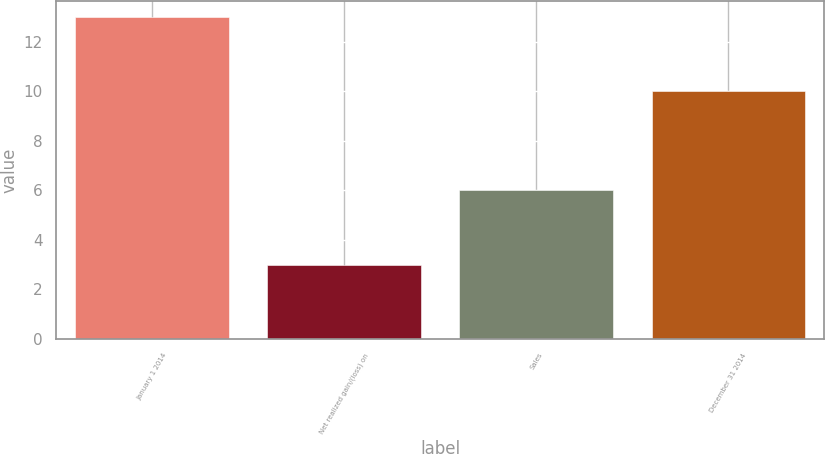Convert chart. <chart><loc_0><loc_0><loc_500><loc_500><bar_chart><fcel>January 1 2014<fcel>Net realized gain/(loss) on<fcel>Sales<fcel>December 31 2014<nl><fcel>13<fcel>3<fcel>6<fcel>10<nl></chart> 